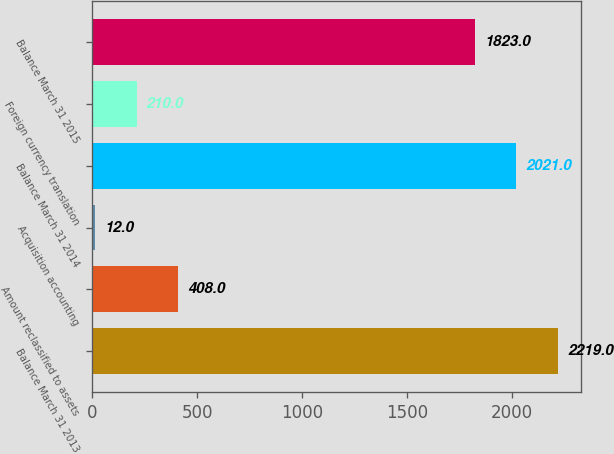Convert chart to OTSL. <chart><loc_0><loc_0><loc_500><loc_500><bar_chart><fcel>Balance March 31 2013<fcel>Amount reclassified to assets<fcel>Acquisition accounting<fcel>Balance March 31 2014<fcel>Foreign currency translation<fcel>Balance March 31 2015<nl><fcel>2219<fcel>408<fcel>12<fcel>2021<fcel>210<fcel>1823<nl></chart> 